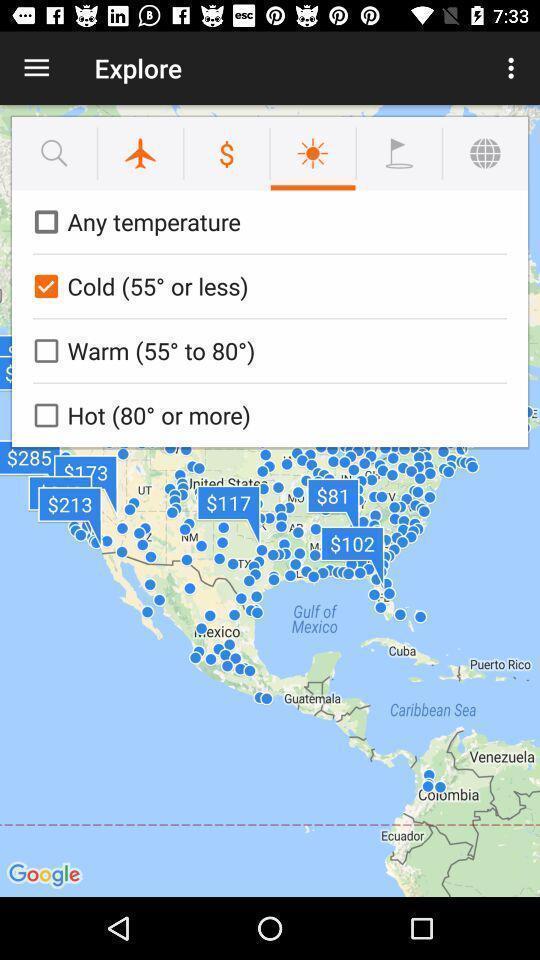Provide a textual representation of this image. Temperatures of places in weather app. 